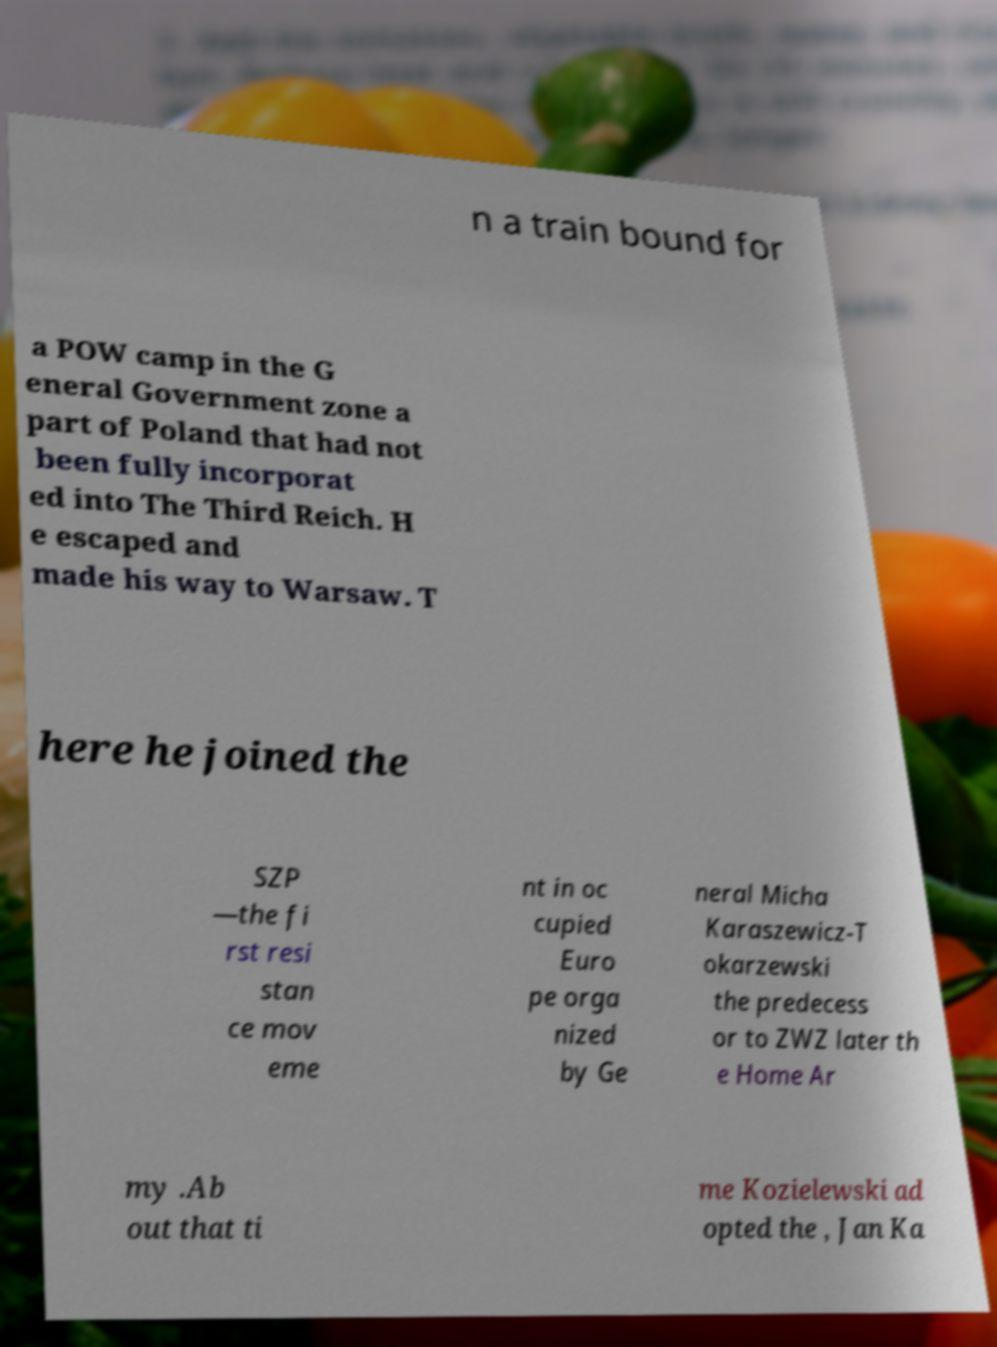Could you assist in decoding the text presented in this image and type it out clearly? n a train bound for a POW camp in the G eneral Government zone a part of Poland that had not been fully incorporat ed into The Third Reich. H e escaped and made his way to Warsaw. T here he joined the SZP —the fi rst resi stan ce mov eme nt in oc cupied Euro pe orga nized by Ge neral Micha Karaszewicz-T okarzewski the predecess or to ZWZ later th e Home Ar my .Ab out that ti me Kozielewski ad opted the , Jan Ka 